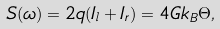Convert formula to latex. <formula><loc_0><loc_0><loc_500><loc_500>S ( \omega ) = 2 q ( I _ { l } + I _ { r } ) = 4 G k _ { B } \Theta ,</formula> 